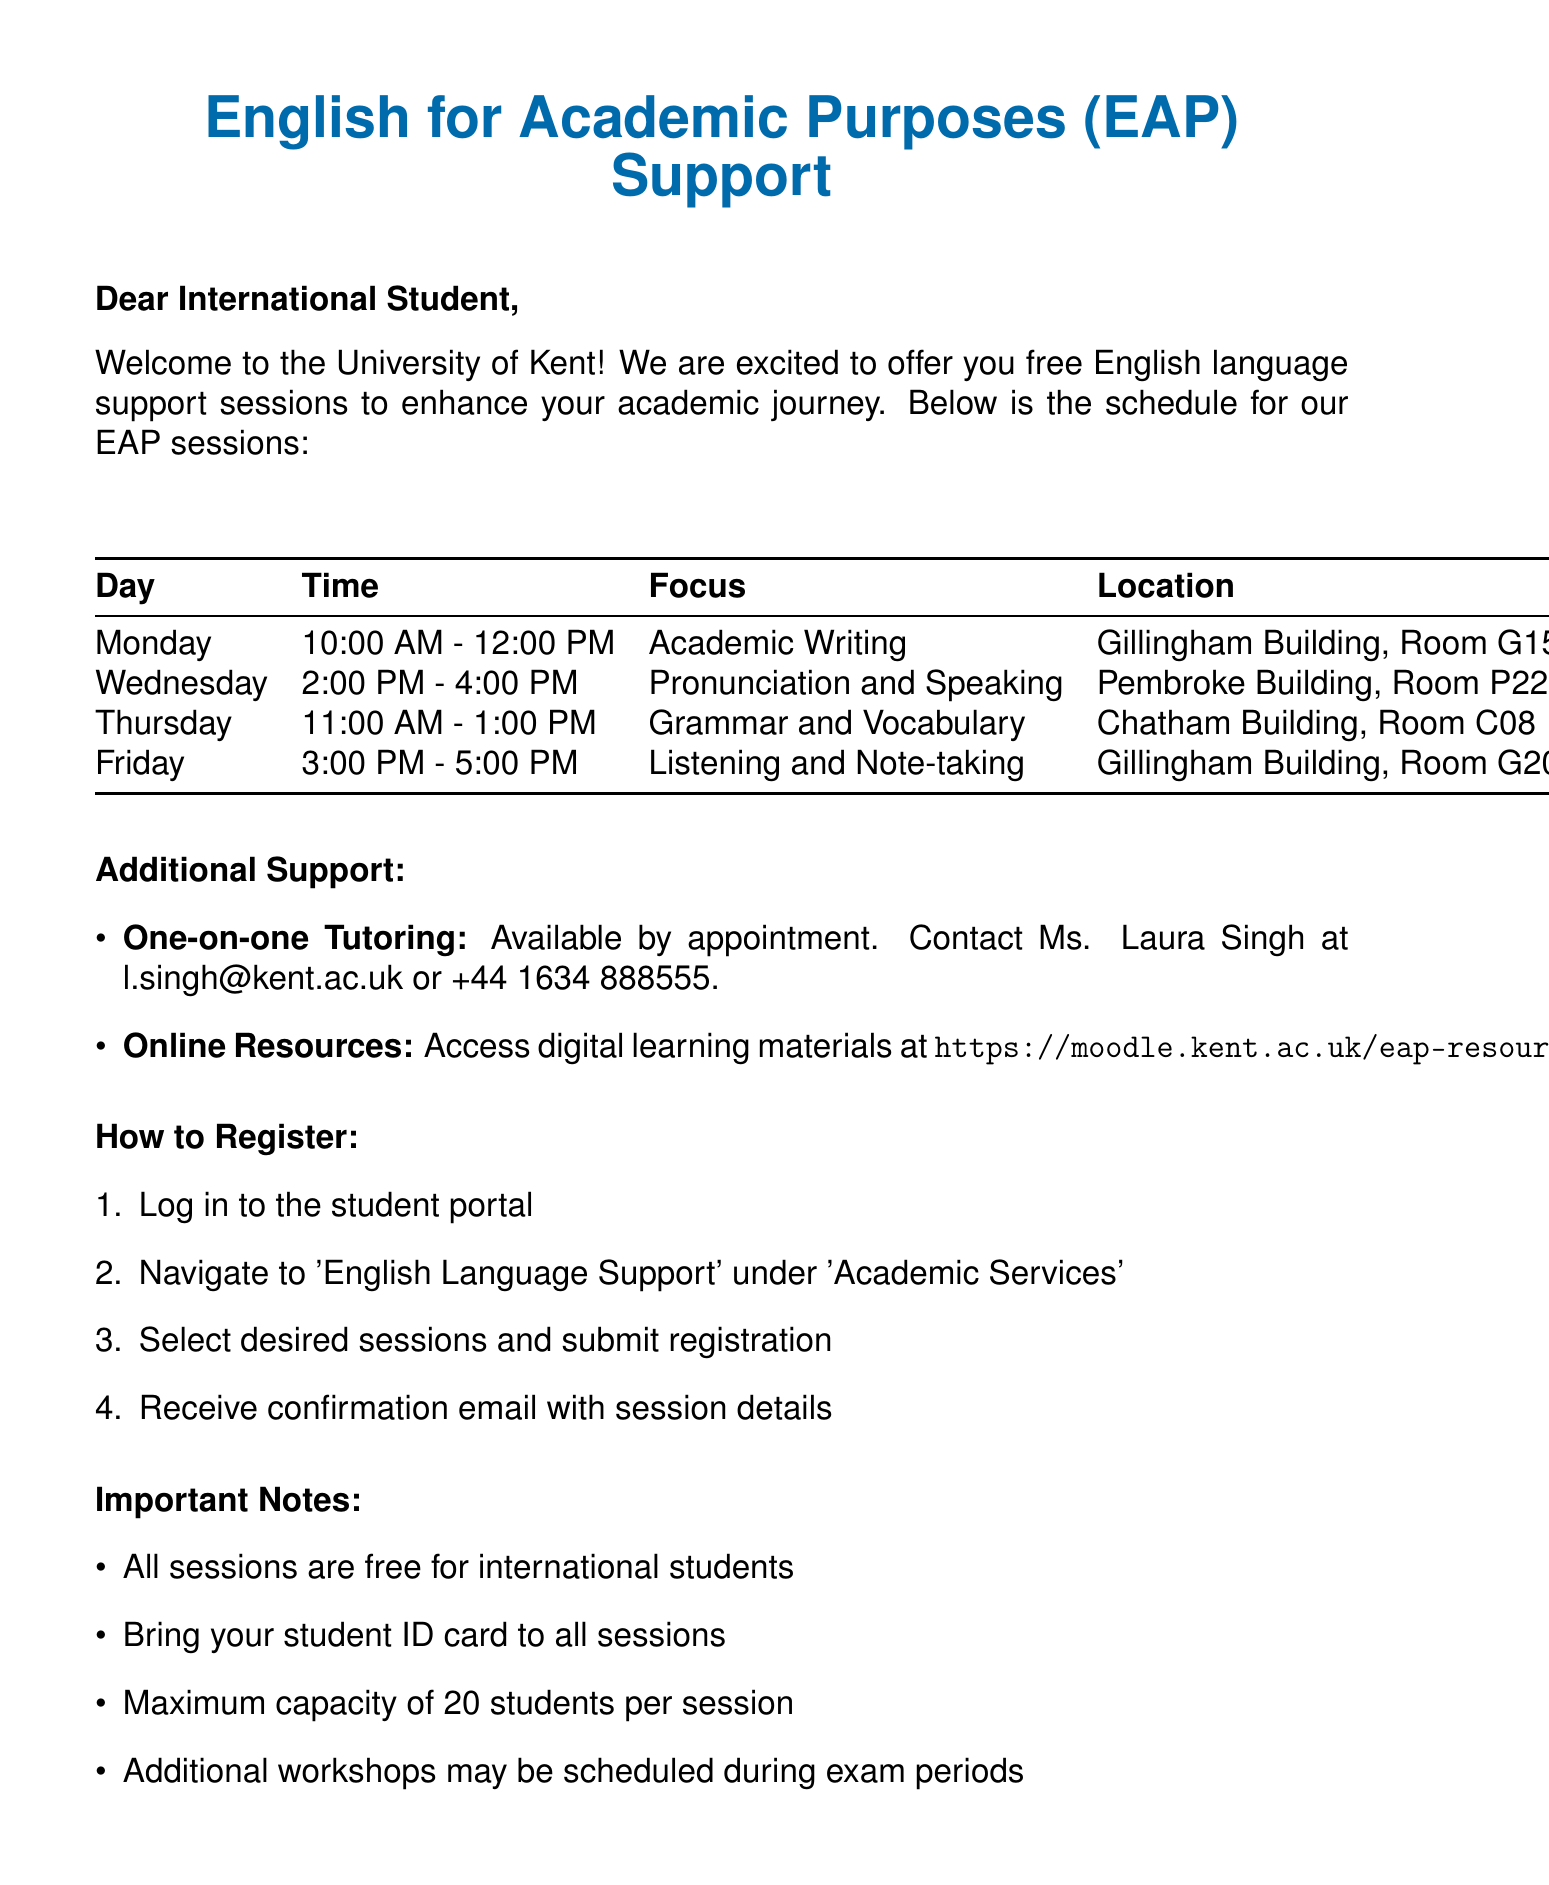What day is the session focusing on Academic Writing? The schedule indicates that the session for Academic Writing is held on Monday.
Answer: Monday Who is the tutor for the Pronunciation and Speaking session? According to the document, the tutor for this session is Mr. James Walker.
Answer: Mr. James Walker What is the maximum capacity for each session? The important notes specify that the maximum capacity of each session is 20 students.
Answer: 20 students Where will the Grammar and Vocabulary session take place? The schedule lists the location for this session as Chatham Building, Room C08.
Answer: Chatham Building, Room C08 How can a student register for the English language support sessions? The registration process is outlined as a series of four steps described in the document.
Answer: Log in to the student portal What time does the Listening and Note-taking session start? The schedule specifies that this session starts at 3:00 PM on Friday.
Answer: 3:00 PM Who can students contact for one-on-one tutoring? The document states that students can contact Ms. Laura Singh for one-on-one tutoring.
Answer: Ms. Laura Singh What email address should students use for International Student Support? The contact information provided shows that the email address is international@kent.ac.uk.
Answer: international@kent.ac.uk Is there any cost associated with the English language support sessions for international students? The important notes clearly mention that all sessions are free for international students.
Answer: Free 